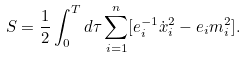Convert formula to latex. <formula><loc_0><loc_0><loc_500><loc_500>S = \frac { 1 } { 2 } \int _ { 0 } ^ { T } d \tau \sum _ { i = 1 } ^ { n } [ e _ { i } ^ { - 1 } \dot { x } _ { i } ^ { 2 } - e _ { i } m _ { i } ^ { 2 } ] .</formula> 